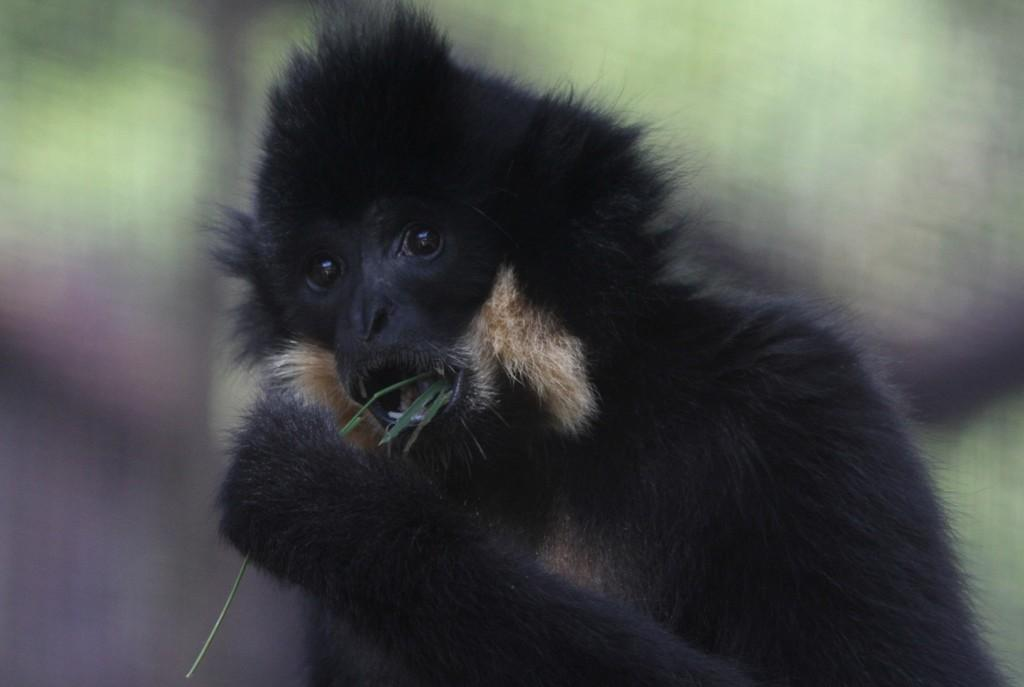What animal is the main subject of the picture? There is a chimpanzee in the picture. Where is the chimpanzee located in the image? The chimpanzee is in the middle of the image. What is the color of the chimpanzee? The chimpanzee is black in color. What type of star can be seen in the picture? There is no star present in the picture; it features a chimpanzee. What advice might the chimpanzee's grandmother give in the image? There is no grandmother present in the image, as it features a chimpanzee. 